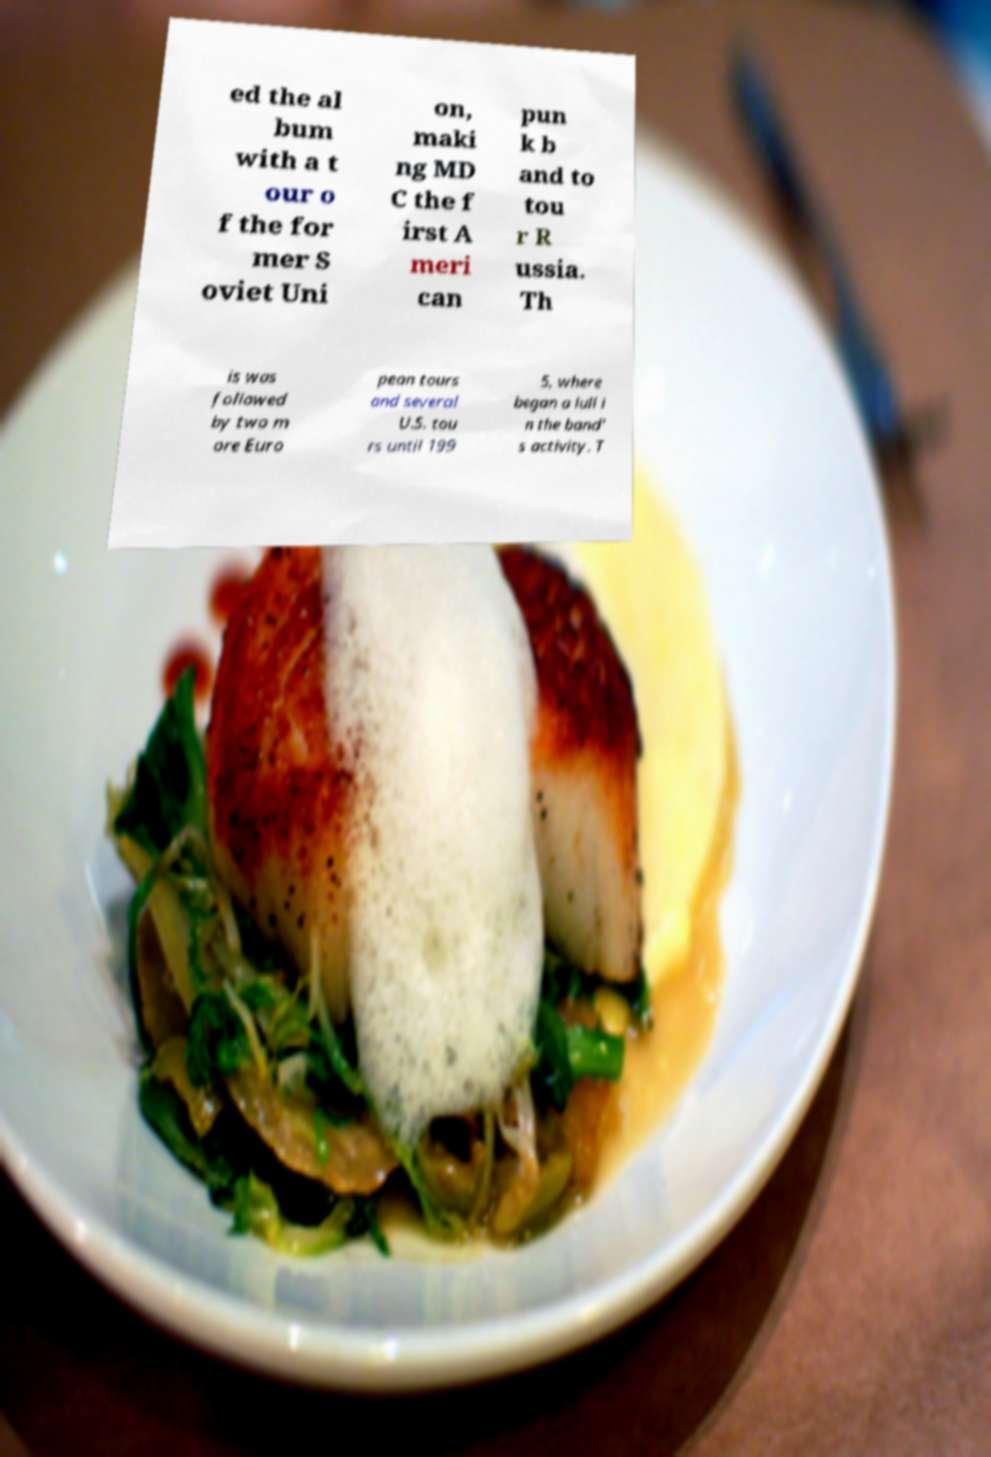Can you read and provide the text displayed in the image?This photo seems to have some interesting text. Can you extract and type it out for me? ed the al bum with a t our o f the for mer S oviet Uni on, maki ng MD C the f irst A meri can pun k b and to tou r R ussia. Th is was followed by two m ore Euro pean tours and several U.S. tou rs until 199 5, where began a lull i n the band' s activity. T 